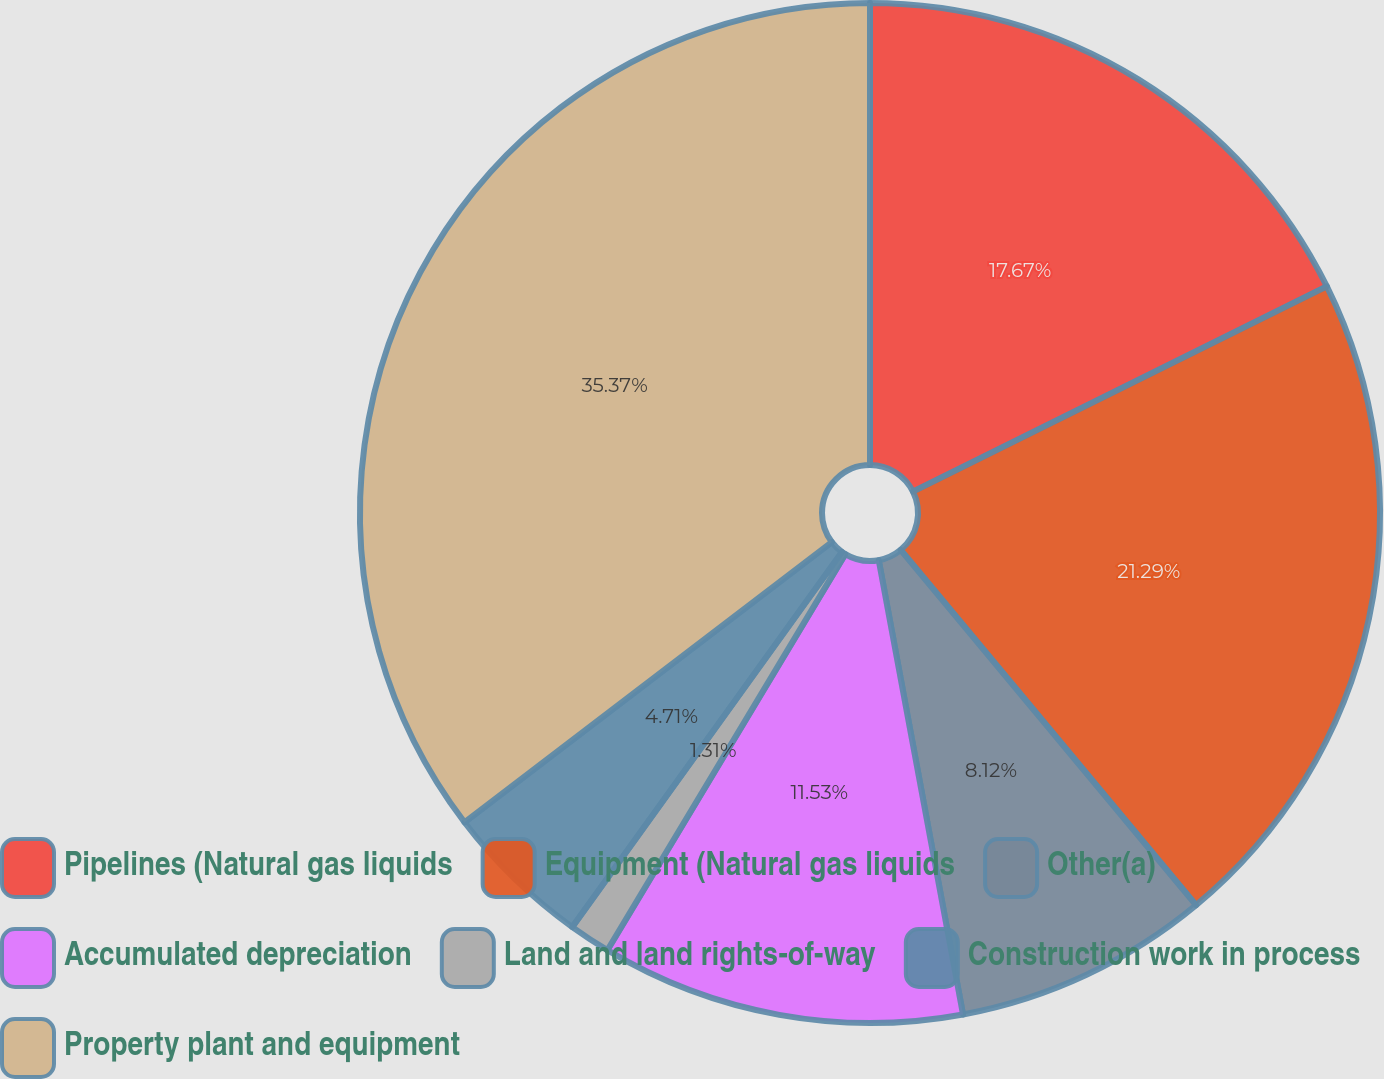Convert chart. <chart><loc_0><loc_0><loc_500><loc_500><pie_chart><fcel>Pipelines (Natural gas liquids<fcel>Equipment (Natural gas liquids<fcel>Other(a)<fcel>Accumulated depreciation<fcel>Land and land rights-of-way<fcel>Construction work in process<fcel>Property plant and equipment<nl><fcel>17.67%<fcel>21.29%<fcel>8.12%<fcel>11.53%<fcel>1.31%<fcel>4.71%<fcel>35.37%<nl></chart> 